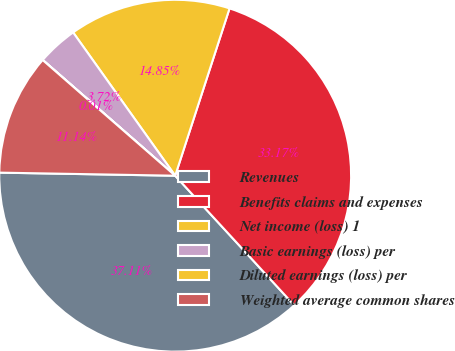Convert chart to OTSL. <chart><loc_0><loc_0><loc_500><loc_500><pie_chart><fcel>Revenues<fcel>Benefits claims and expenses<fcel>Net income (loss) 1<fcel>Basic earnings (loss) per<fcel>Diluted earnings (loss) per<fcel>Weighted average common shares<nl><fcel>37.11%<fcel>33.17%<fcel>14.85%<fcel>3.72%<fcel>0.01%<fcel>11.14%<nl></chart> 